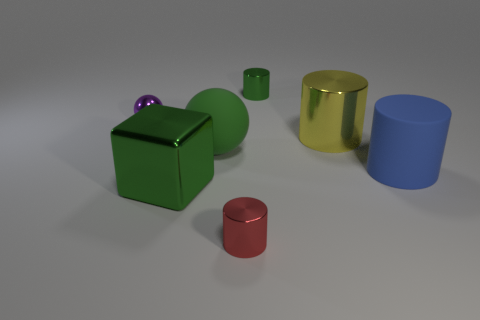How does the lighting affect the appearance of the colors in the scene? The lighting in the scene casts soft shadows and highlights that create depth and enhance the vibrancy of the colors, giving each object a distinct and appealing visual presence. 